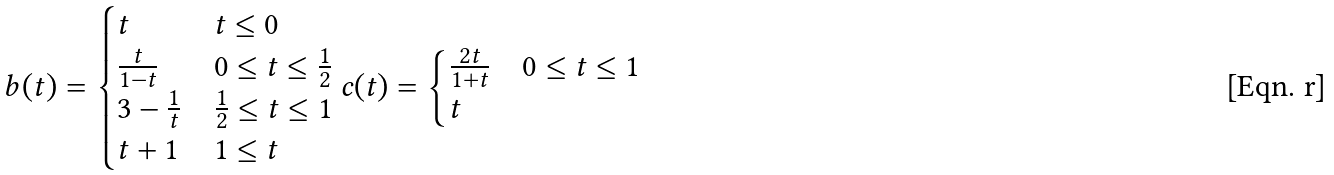<formula> <loc_0><loc_0><loc_500><loc_500>b ( t ) = \begin{cases} t & t \leq 0 \\ \frac { t } { 1 - t } & 0 \leq t \leq \frac { 1 } { 2 } \\ 3 - \frac { 1 } { t } & \frac { 1 } { 2 } \leq t \leq 1 \\ t + 1 & 1 \leq t \\ \end{cases} c ( t ) = \begin{cases} \frac { 2 t } { 1 + t } & 0 \leq t \leq 1 \\ t & \\ \end{cases}</formula> 